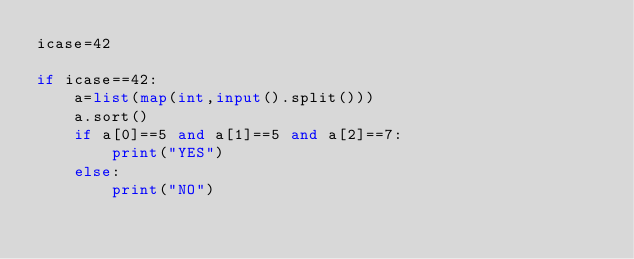<code> <loc_0><loc_0><loc_500><loc_500><_Python_>icase=42

if icase==42:
    a=list(map(int,input().split()))
    a.sort()
    if a[0]==5 and a[1]==5 and a[2]==7:
        print("YES")
    else:
        print("NO")</code> 